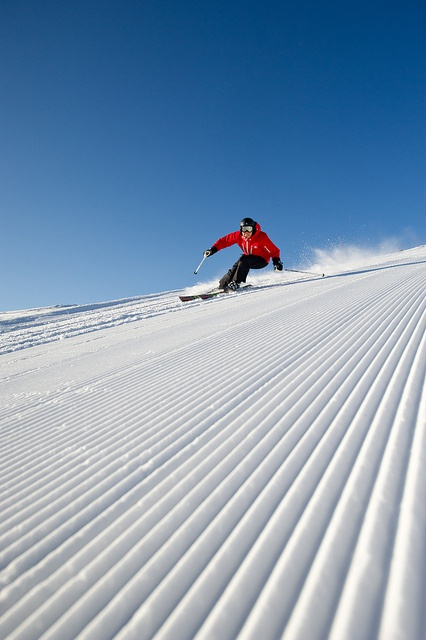Describe the objects in this image and their specific colors. I can see people in blue, black, maroon, and gray tones and skis in blue, black, gray, darkgray, and maroon tones in this image. 